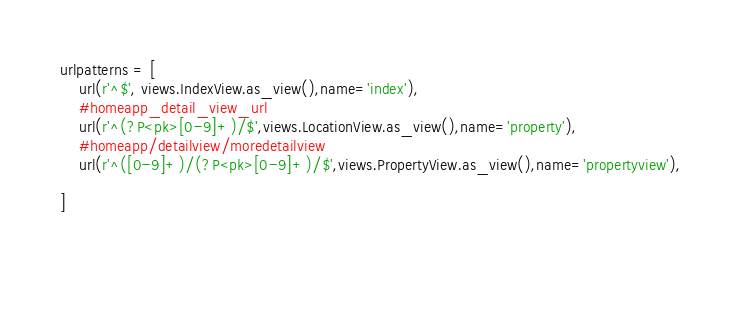<code> <loc_0><loc_0><loc_500><loc_500><_Python_>
urlpatterns = [
    url(r'^$', views.IndexView.as_view(),name='index'),
    #homeapp_detail_view_url
    url(r'^(?P<pk>[0-9]+)/$',views.LocationView.as_view(),name='property'),
    #homeapp/detailview/moredetailview
    url(r'^([0-9]+)/(?P<pk>[0-9]+)/$',views.PropertyView.as_view(),name='propertyview'),

]

    </code> 